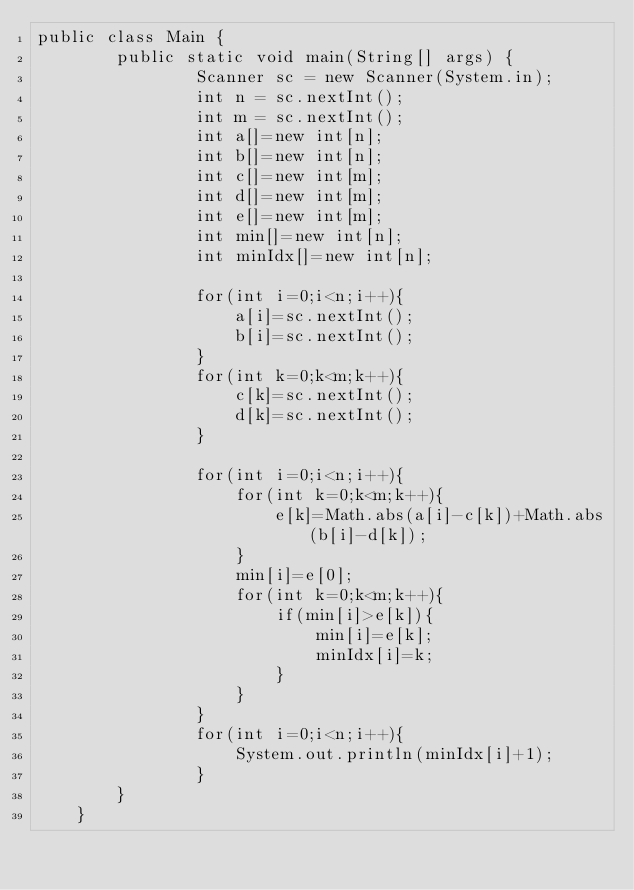Convert code to text. <code><loc_0><loc_0><loc_500><loc_500><_Java_>public class Main {
		public static void main(String[] args) {
				Scanner sc = new Scanner(System.in);
				int n = sc.nextInt();
				int m = sc.nextInt();
				int a[]=new int[n];
				int b[]=new int[n];
				int c[]=new int[m];
				int d[]=new int[m];
				int e[]=new int[m];
				int min[]=new int[n];
				int minIdx[]=new int[n];
				
				for(int i=0;i<n;i++){
					a[i]=sc.nextInt();
					b[i]=sc.nextInt();
				}
				for(int k=0;k<m;k++){
					c[k]=sc.nextInt();
					d[k]=sc.nextInt();
				}
				
				for(int i=0;i<n;i++){
					for(int k=0;k<m;k++){
						e[k]=Math.abs(a[i]-c[k])+Math.abs(b[i]-d[k]);
					}
					min[i]=e[0];
					for(int k=0;k<m;k++){
						if(min[i]>e[k]){
							min[i]=e[k];
							minIdx[i]=k;
						}
					}
				}
				for(int i=0;i<n;i++){
					System.out.println(minIdx[i]+1);
				}
		}		
	}</code> 